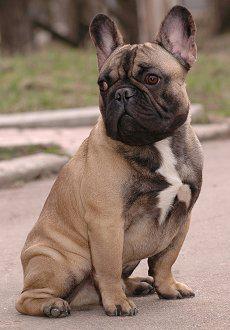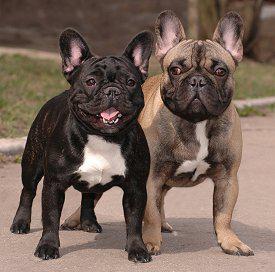The first image is the image on the left, the second image is the image on the right. Given the left and right images, does the statement "At least one of the dogs is in the grass." hold true? Answer yes or no. No. 